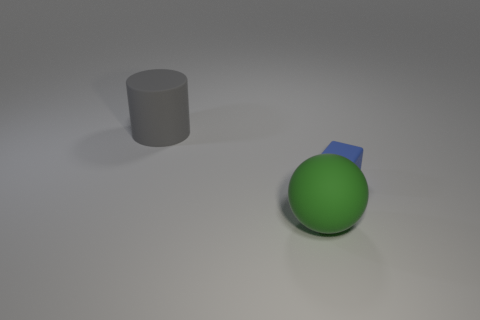Add 2 spheres. How many objects exist? 5 Subtract all blocks. How many objects are left? 2 Subtract 0 cyan spheres. How many objects are left? 3 Subtract 1 cylinders. How many cylinders are left? 0 Subtract all green cylinders. Subtract all yellow spheres. How many cylinders are left? 1 Subtract all cylinders. Subtract all tiny blue rubber cubes. How many objects are left? 1 Add 3 objects. How many objects are left? 6 Add 1 yellow matte blocks. How many yellow matte blocks exist? 1 